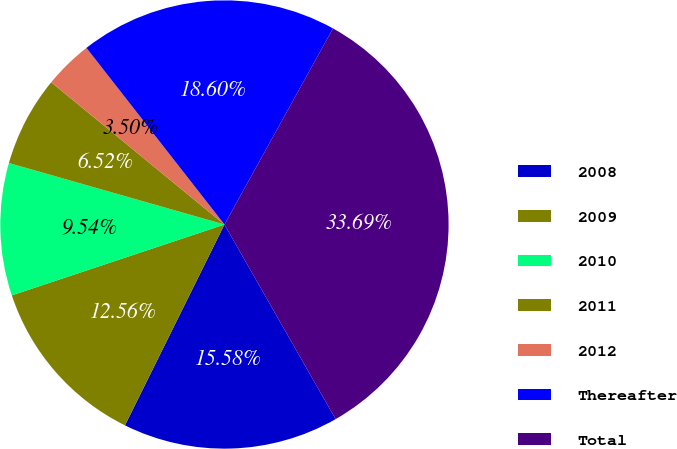Convert chart. <chart><loc_0><loc_0><loc_500><loc_500><pie_chart><fcel>2008<fcel>2009<fcel>2010<fcel>2011<fcel>2012<fcel>Thereafter<fcel>Total<nl><fcel>15.58%<fcel>12.56%<fcel>9.54%<fcel>6.52%<fcel>3.5%<fcel>18.6%<fcel>33.69%<nl></chart> 